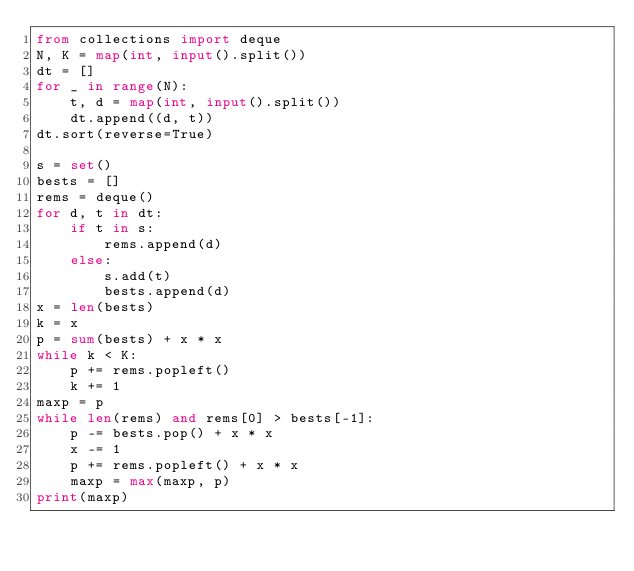Convert code to text. <code><loc_0><loc_0><loc_500><loc_500><_Python_>from collections import deque
N, K = map(int, input().split())
dt = []
for _ in range(N):
    t, d = map(int, input().split())
    dt.append((d, t))
dt.sort(reverse=True)

s = set()
bests = []
rems = deque()
for d, t in dt:
    if t in s:
        rems.append(d)
    else:
        s.add(t)
        bests.append(d)
x = len(bests)
k = x
p = sum(bests) + x * x
while k < K:
    p += rems.popleft()
    k += 1
maxp = p
while len(rems) and rems[0] > bests[-1]:
    p -= bests.pop() + x * x
    x -= 1
    p += rems.popleft() + x * x
    maxp = max(maxp, p)
print(maxp)
</code> 